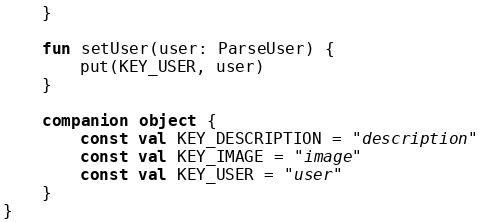Convert code to text. <code><loc_0><loc_0><loc_500><loc_500><_Kotlin_>    }

    fun setUser(user: ParseUser) {
        put(KEY_USER, user)
    }

    companion object {
        const val KEY_DESCRIPTION = "description"
        const val KEY_IMAGE = "image"
        const val KEY_USER = "user"
    }
}</code> 